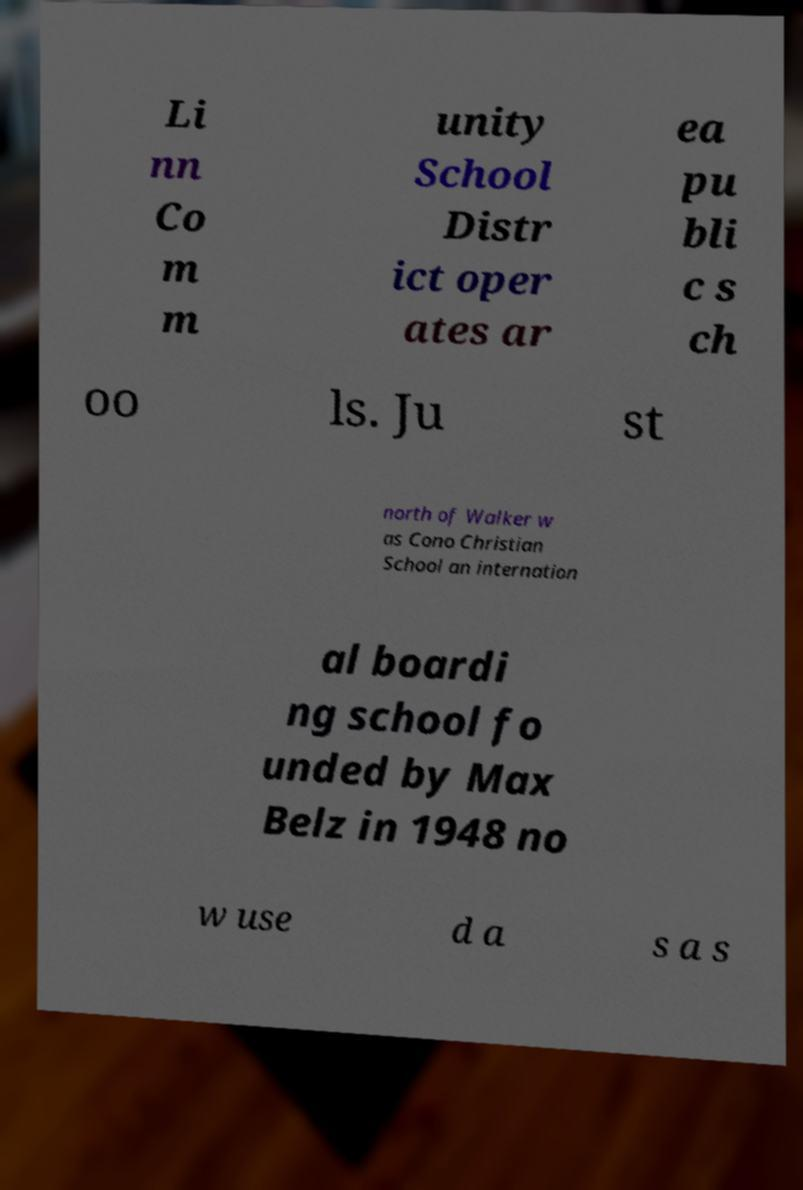Could you extract and type out the text from this image? Li nn Co m m unity School Distr ict oper ates ar ea pu bli c s ch oo ls. Ju st north of Walker w as Cono Christian School an internation al boardi ng school fo unded by Max Belz in 1948 no w use d a s a s 